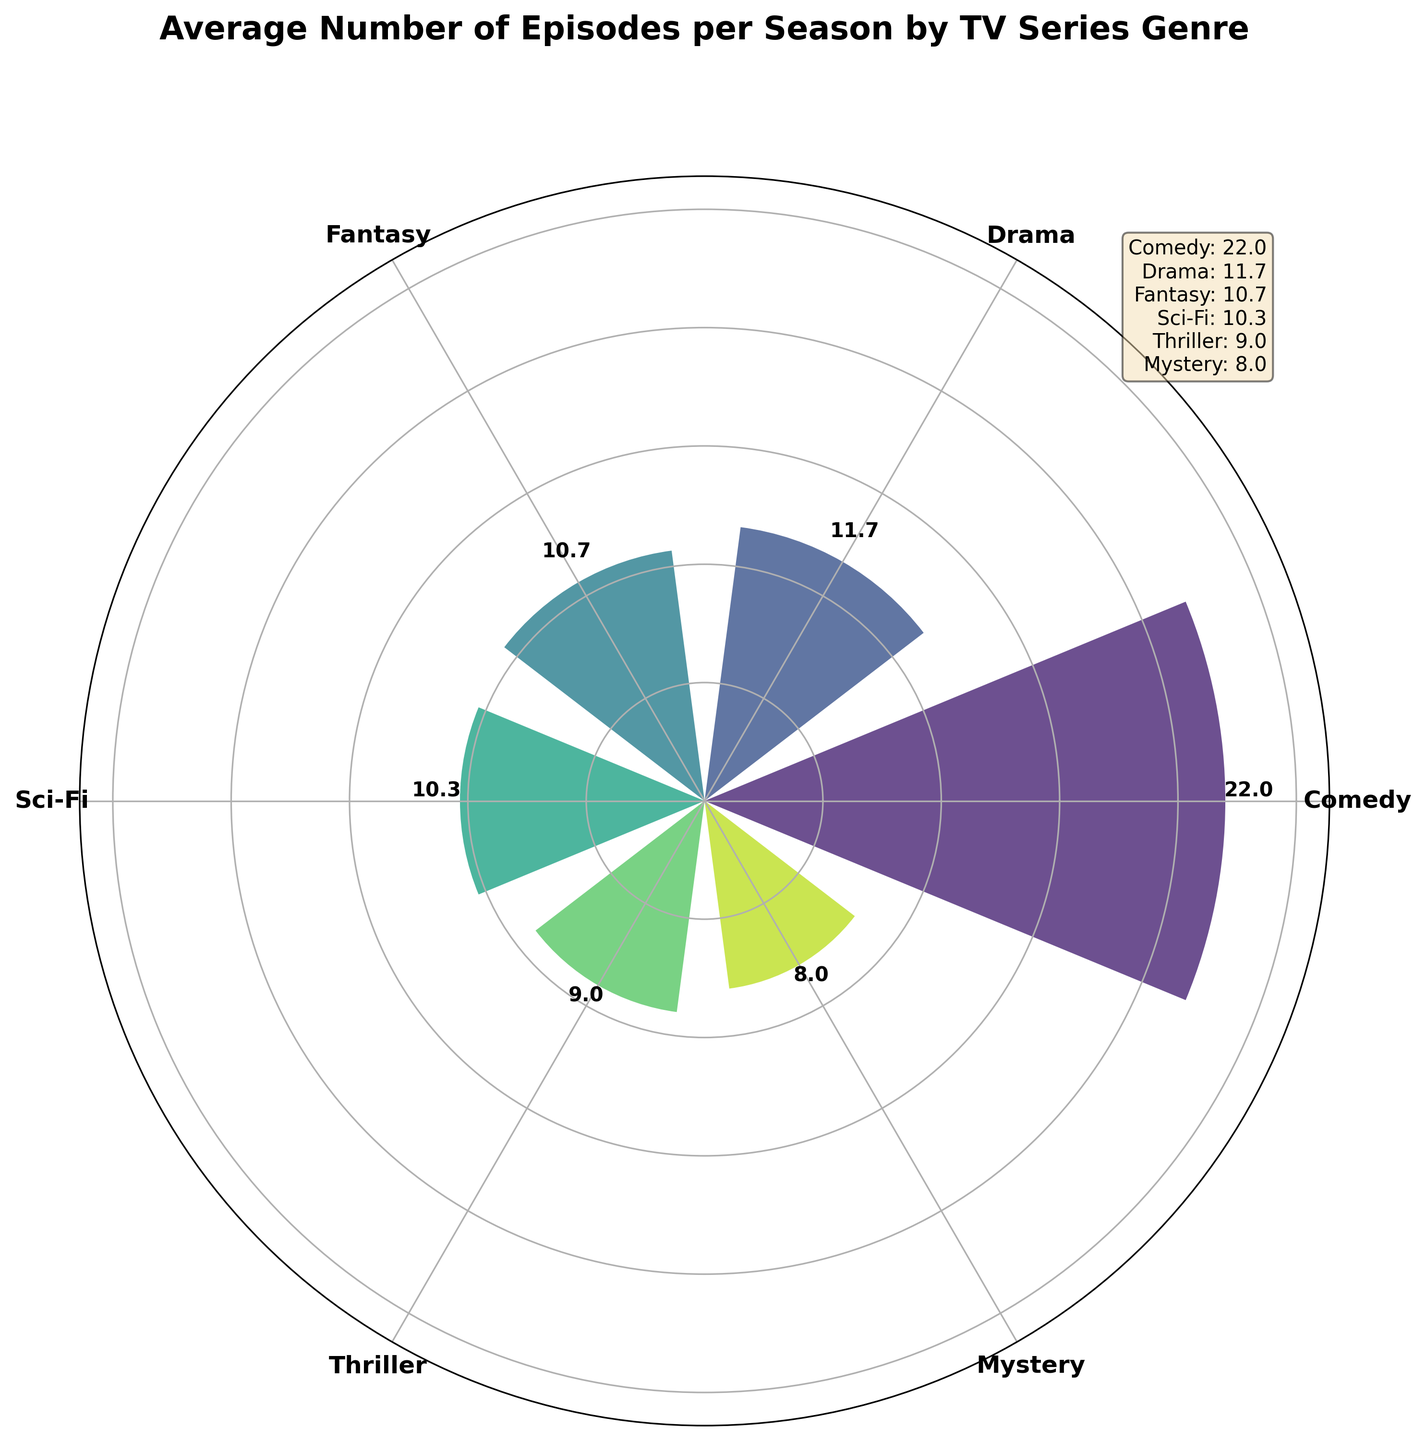What is the title of the polar area chart? The title of the chart is displayed at the top. It is the largest and boldest text on the figure.
Answer: "Average Number of Episodes per Season by TV Series Genre" How many genres are represented in the chart? The chart uses different bars radiating from the center, each labeled with a genre. Count the unique labels.
Answer: 6 Which genre has the highest average number of episodes per season? Look at the outermost bar (the longest bar), which represents the highest value. Its corresponding label indicates the genre.
Answer: Comedy What is the average number of episodes per season for the Mystery genre? Locate the bar labeled "Mystery" and read the number adjacent to the top of the bar.
Answer: 8.0 How does the average number of episodes per season for Drama compare to Sci-Fi? Identify the bars for Drama and Sci-Fi, and compare their lengths and the values displayed above them. Drama has a slightly longer bar than Sci-Fi.
Answer: Drama is higher than Sci-Fi What is the sum of the average number of episodes per season for Comedy and Thriller? Identify the values for Comedy and Thriller (24 and 9, respectively) and add them together.
Answer: 24.0 + 9.0 = 33.0 Which genres have an average number of episodes between 8 and 12? Identify the bars whose values fall within the 8 to 12 range and note their labels.
Answer: Sci-Fi, Fantasy, Thriller, Mystery What is the difference in the average number of episodes per season between the genre with the most episodes and the genre with the fewest episodes? Identify the highest and lowest values (Comedy and Mystery) and subtract the lowest from the highest.
Answer: 20.8 - 8.0 = 12.8 What is the median value of the average number of episodes across all genres? List the average values, sort them, and find the middle value. The sorted values are: 8.0, 8.0, 10.7, 12.0, 20.8. The median value is the middle one.
Answer: 10.7 